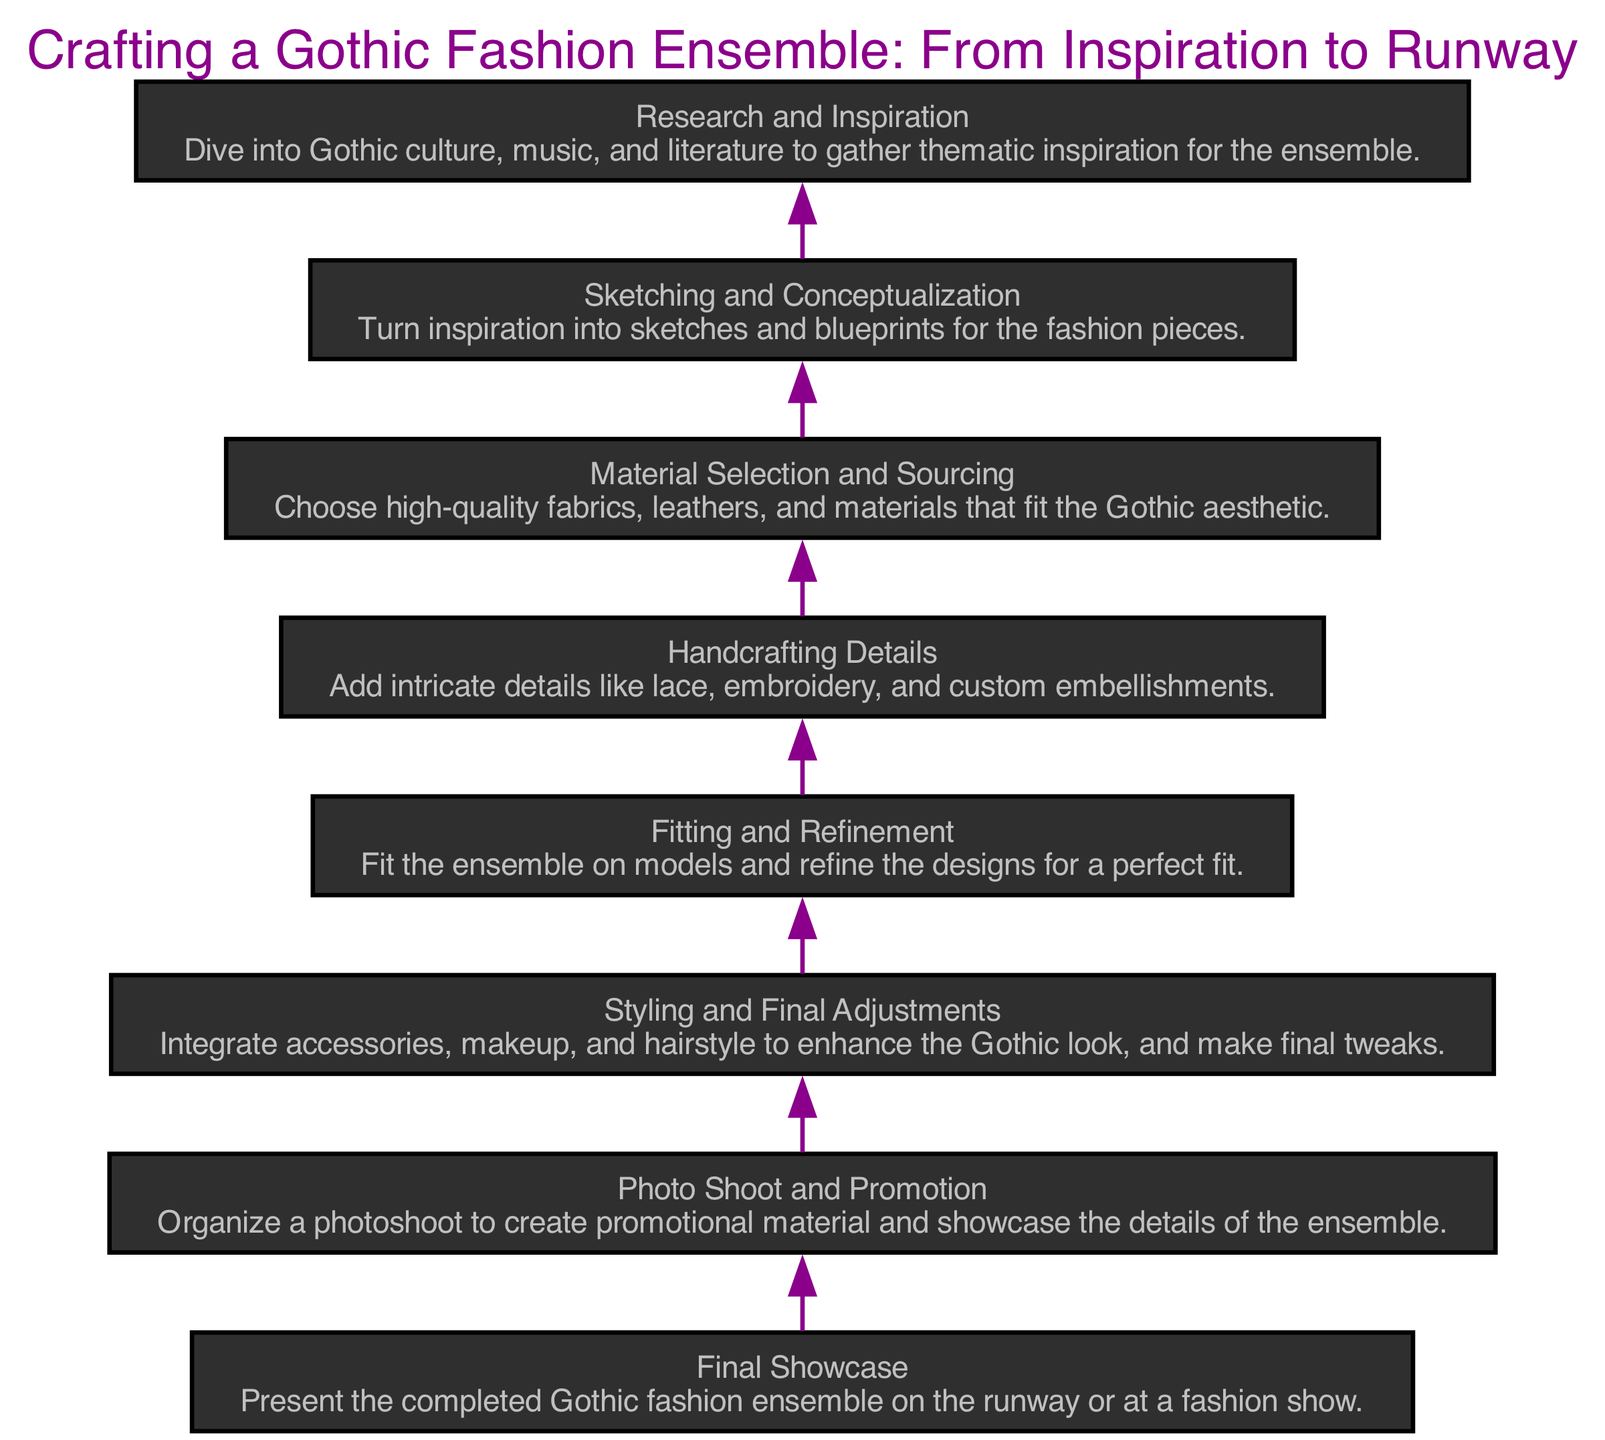What is the first stage in the diagram? The first stage (at the bottom of the flow chart) is "Research and Inspiration" which involves diving into Gothic culture, music, and literature for thematic ideas.
Answer: Research and Inspiration How many total stages are there in the diagram? By counting the nodes in the flow chart, there are eight stages listed from "Research and Inspiration" to "Final Showcase".
Answer: 8 What stage comes right before "Fitting and Refinement"? The stage that comes right before "Fitting and Refinement" is "Material Selection and Sourcing" which involves choosing appropriate fabrics and materials.
Answer: Material Selection and Sourcing What is the final stage of the flow chart? The final stage indicated at the top of the flow chart is "Final Showcase" where the ensemble is presented.
Answer: Final Showcase What activities are involved in "Photo Shoot and Promotion"? According to the diagram, "Photo Shoot and Promotion" includes organizing a photoshoot to create promotional material and showcase the ensemble's details.
Answer: Organize a photoshoot Which stage directly leads to "Styling and Final Adjustments"? The stage that directly leads to "Styling and Final Adjustments" is "Fitting and Refinement", indicating a progression in preparing the ensemble.
Answer: Fitting and Refinement What is the purpose of the "Handcrafting Details" stage? The purpose of the "Handcrafting Details" stage is to add intricate features such as lace, embroidery, and embellishments that enhance the Gothic aesthetic.
Answer: Add intricate details What connects "Sketching and Conceptualization" to "Material Selection and Sourcing"? "Sketching and Conceptualization" leads into "Material Selection and Sourcing", indicating that the sketches inform the choices of materials needed for the designs.
Answer: Sketching informs material choices What does "Styling and Final Adjustments" enhance in the ensemble? "Styling and Final Adjustments" enhances the overall Gothic look through the integration of accessories, makeup, and hairstyle.
Answer: Enhances the Gothic look 